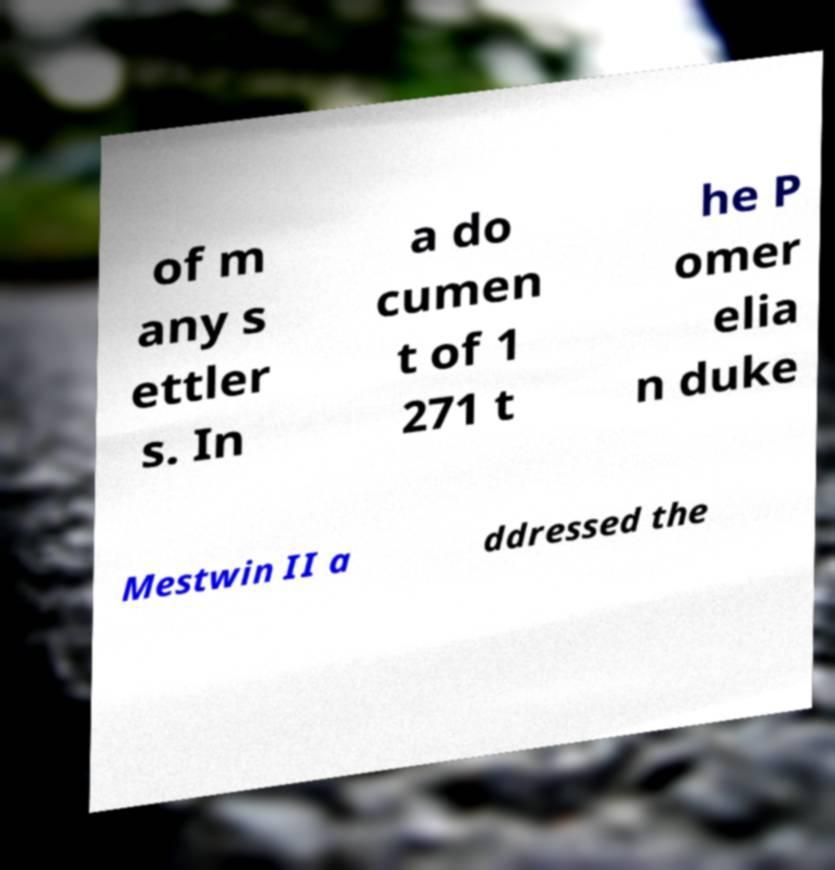I need the written content from this picture converted into text. Can you do that? of m any s ettler s. In a do cumen t of 1 271 t he P omer elia n duke Mestwin II a ddressed the 